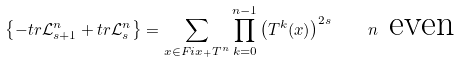Convert formula to latex. <formula><loc_0><loc_0><loc_500><loc_500>\left \{ - t r \mathcal { L } _ { s + 1 } ^ { n } + t r \mathcal { L } _ { s } ^ { n } \right \} = \sum _ { x \in F i x _ { + } T ^ { n } } \prod _ { k = 0 } ^ { n - 1 } \left ( T ^ { k } ( x ) \right ) ^ { 2 s } \quad n \ \text {even}</formula> 